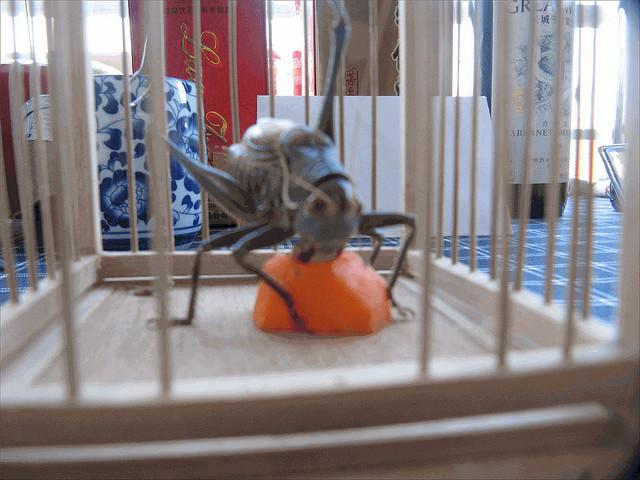What kind of animal do you see in the picture? Please explain your reasoning. insect. The animal in the cage is a cricket which is a kind of insect. 